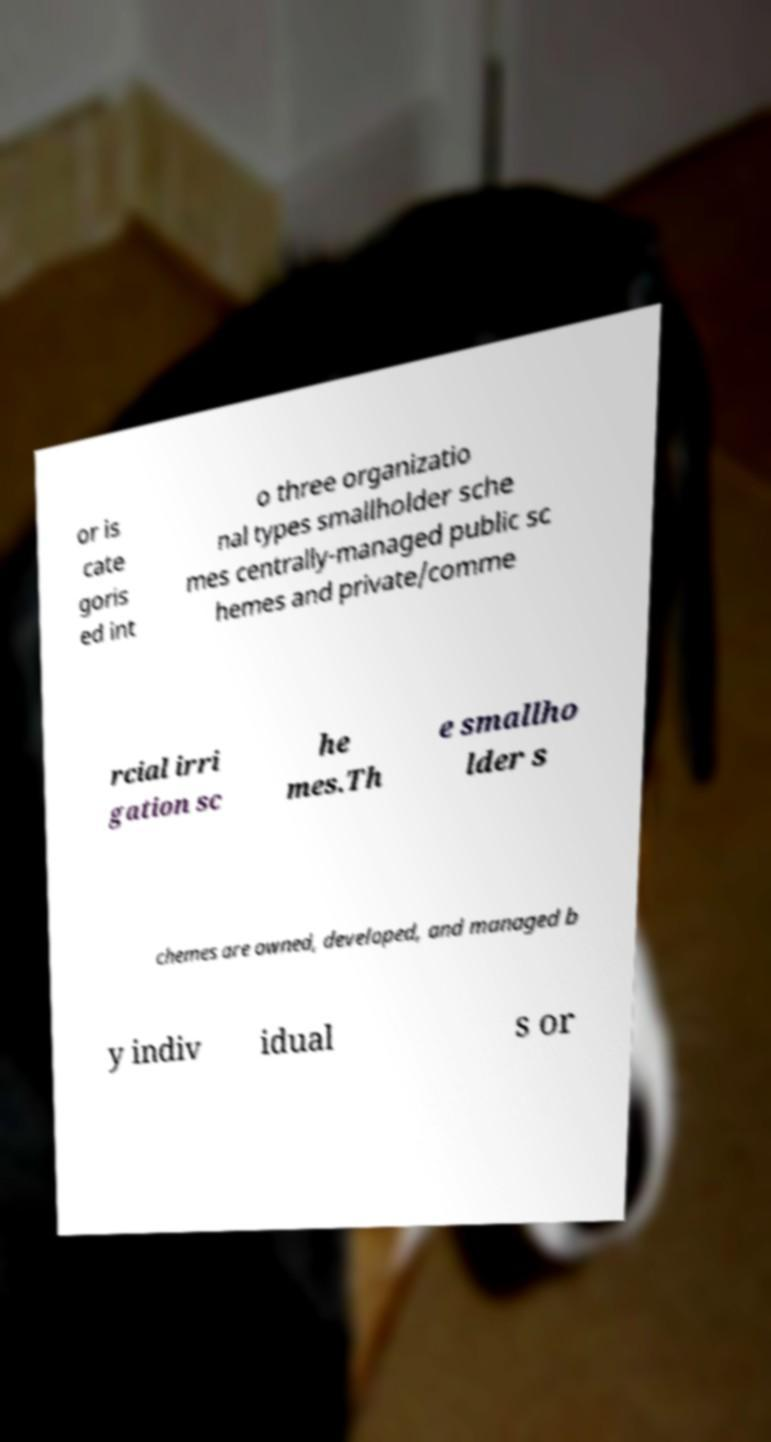Please read and relay the text visible in this image. What does it say? or is cate goris ed int o three organizatio nal types smallholder sche mes centrally-managed public sc hemes and private/comme rcial irri gation sc he mes.Th e smallho lder s chemes are owned, developed, and managed b y indiv idual s or 